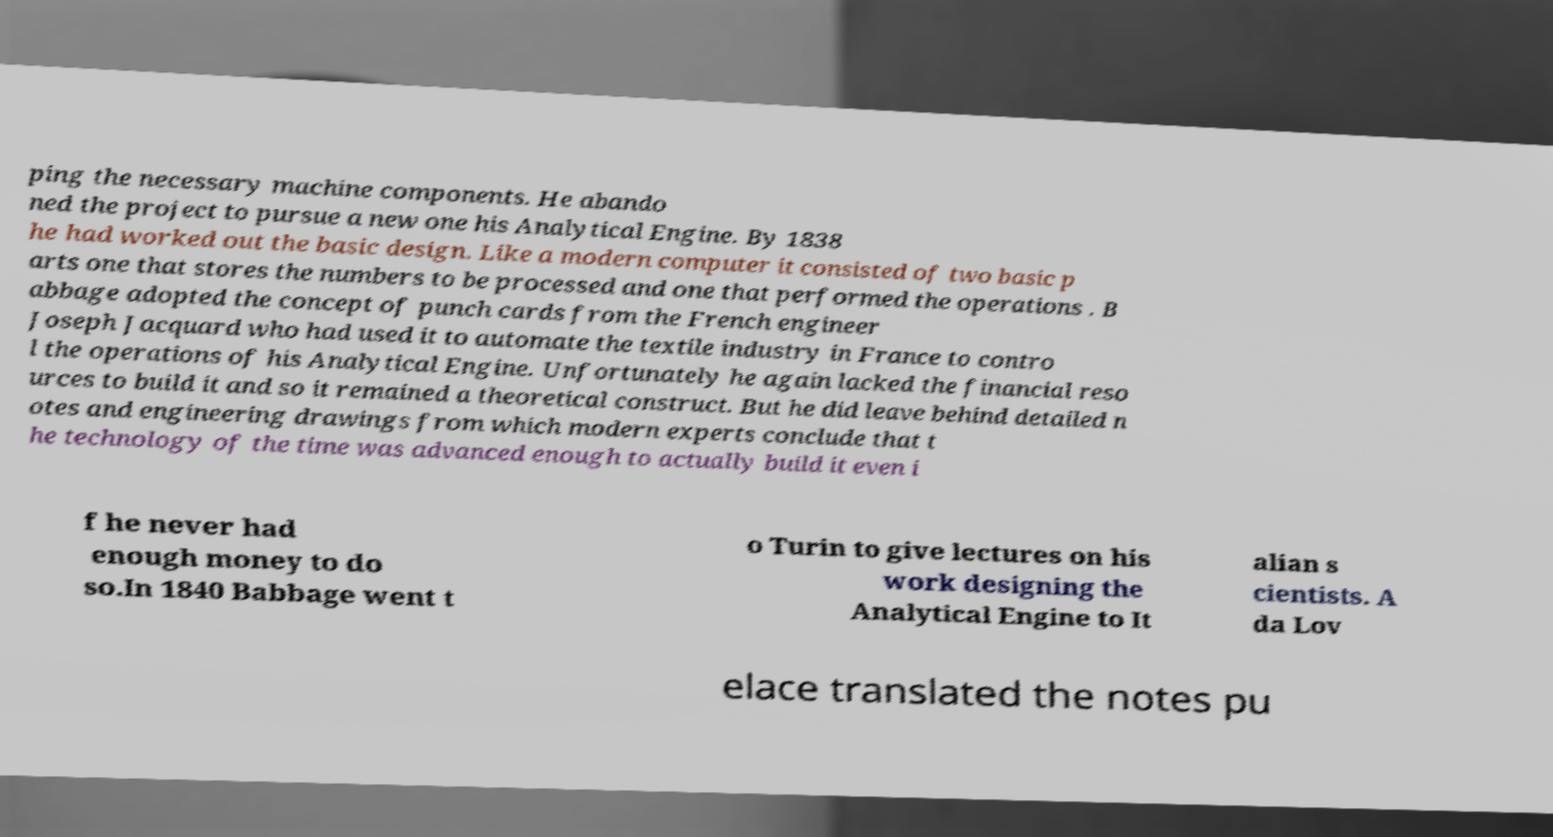Can you accurately transcribe the text from the provided image for me? ping the necessary machine components. He abando ned the project to pursue a new one his Analytical Engine. By 1838 he had worked out the basic design. Like a modern computer it consisted of two basic p arts one that stores the numbers to be processed and one that performed the operations . B abbage adopted the concept of punch cards from the French engineer Joseph Jacquard who had used it to automate the textile industry in France to contro l the operations of his Analytical Engine. Unfortunately he again lacked the financial reso urces to build it and so it remained a theoretical construct. But he did leave behind detailed n otes and engineering drawings from which modern experts conclude that t he technology of the time was advanced enough to actually build it even i f he never had enough money to do so.In 1840 Babbage went t o Turin to give lectures on his work designing the Analytical Engine to It alian s cientists. A da Lov elace translated the notes pu 